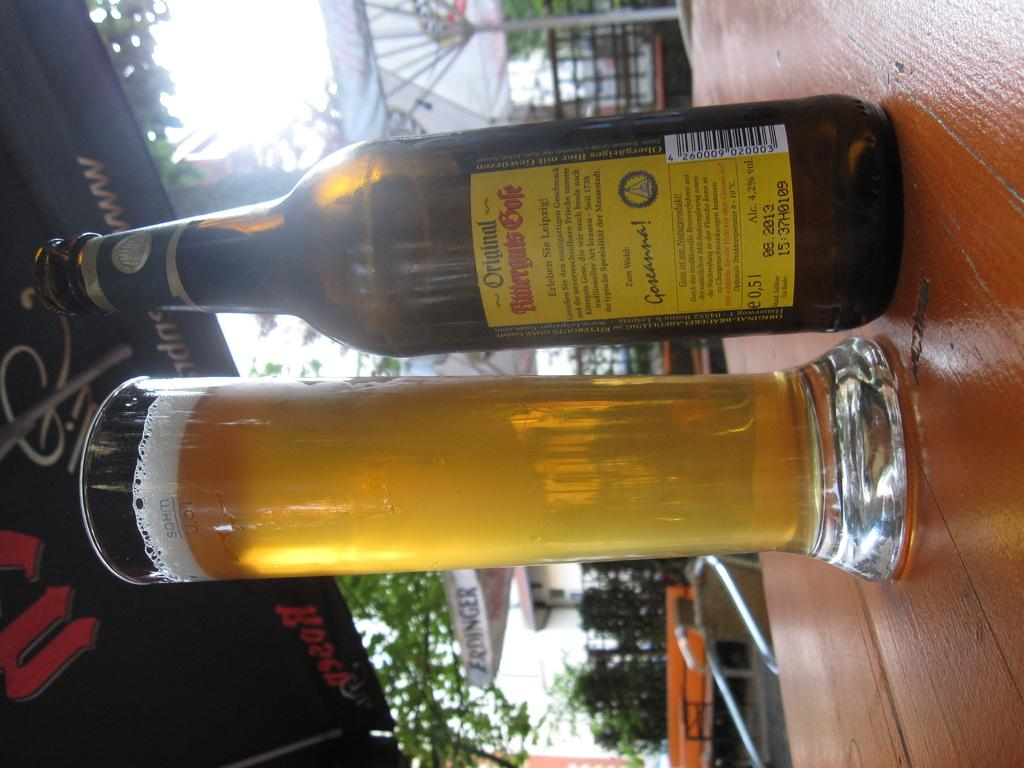<image>
Offer a succinct explanation of the picture presented. A bottle of an alcoholic beverage, which contains 4.2% alcohol, sits next to a glass. 